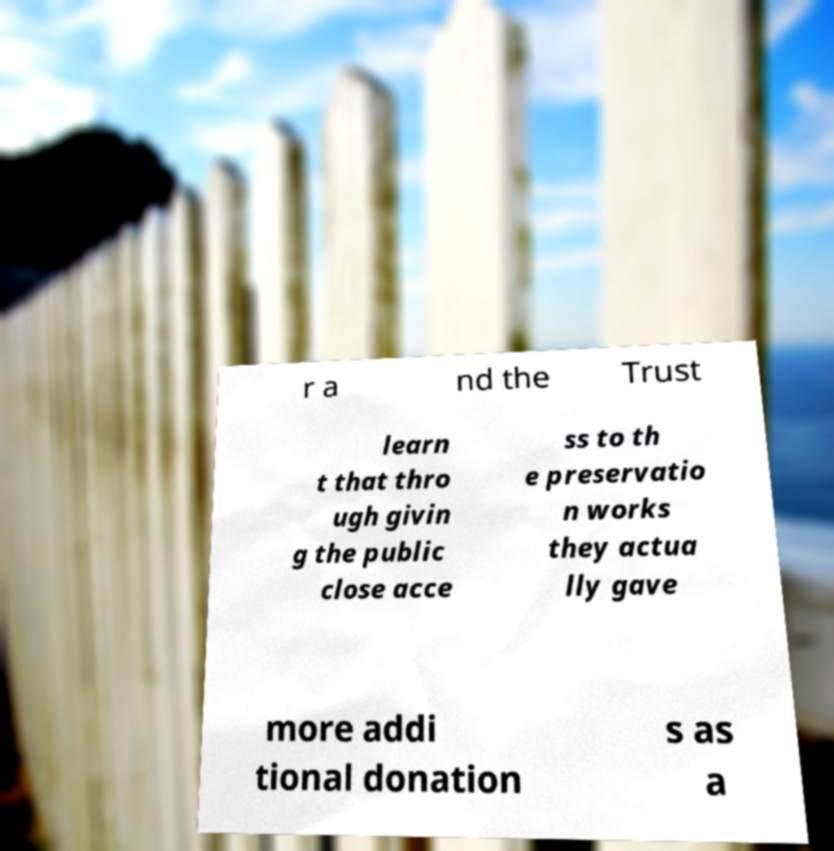There's text embedded in this image that I need extracted. Can you transcribe it verbatim? r a nd the Trust learn t that thro ugh givin g the public close acce ss to th e preservatio n works they actua lly gave more addi tional donation s as a 